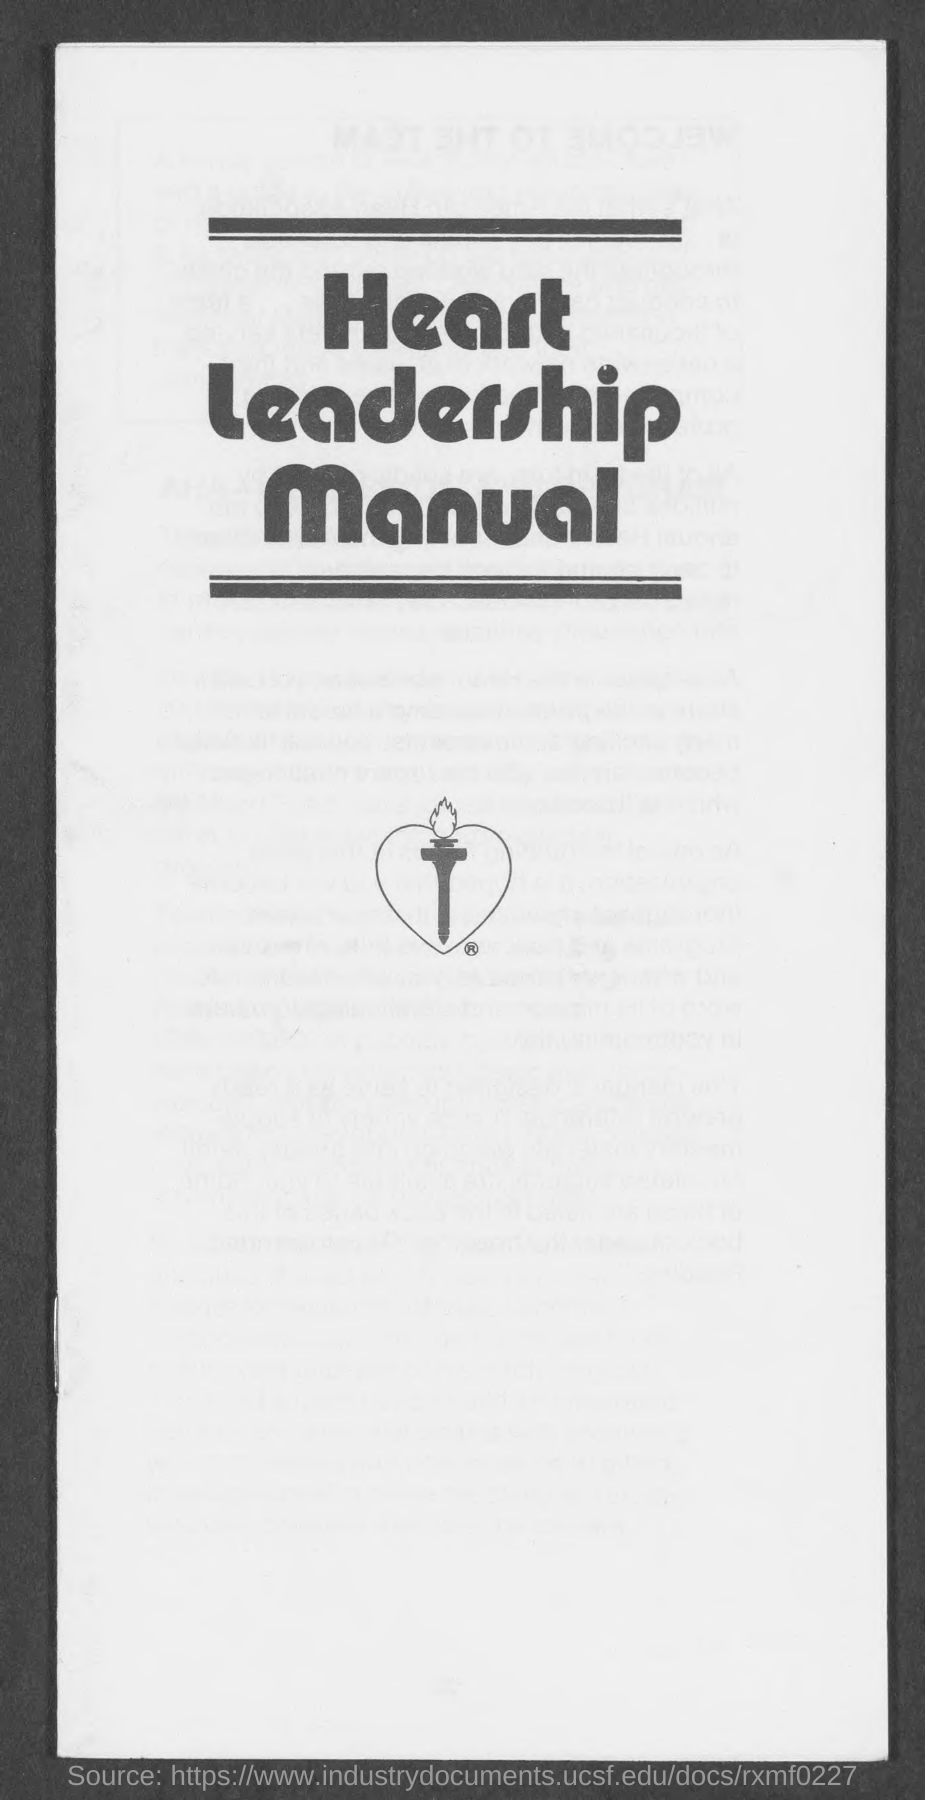What is the title of the manual?
Ensure brevity in your answer.  Heart Leadership manual. 